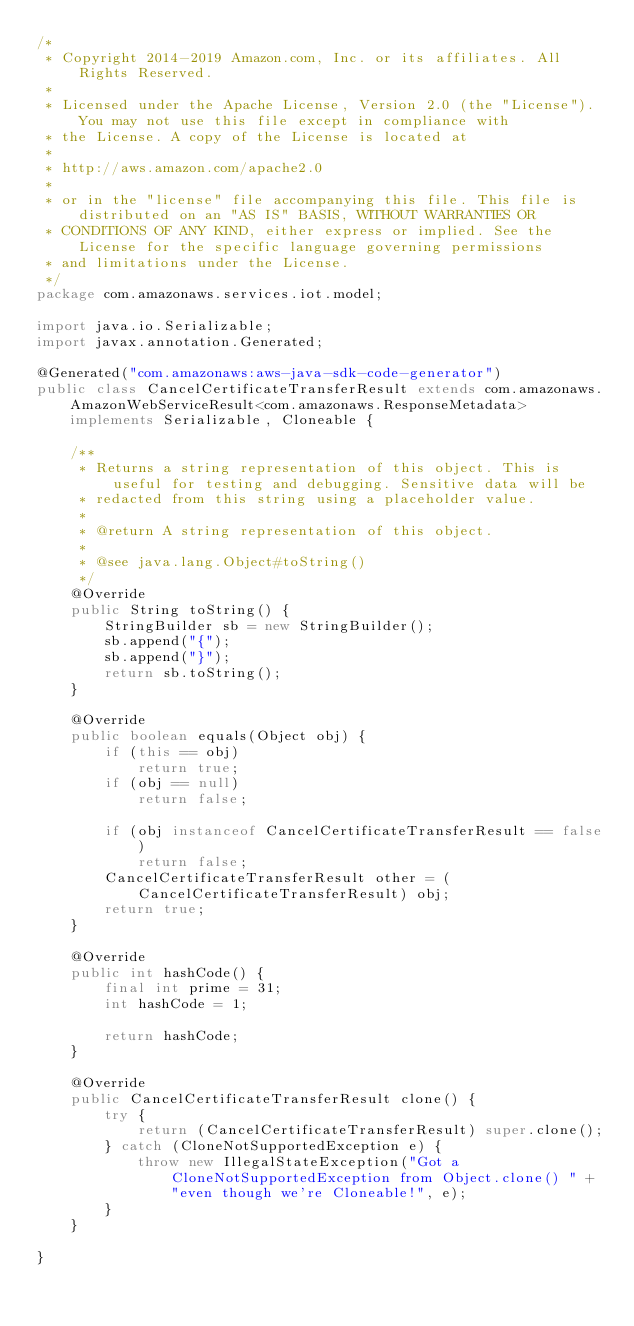<code> <loc_0><loc_0><loc_500><loc_500><_Java_>/*
 * Copyright 2014-2019 Amazon.com, Inc. or its affiliates. All Rights Reserved.
 * 
 * Licensed under the Apache License, Version 2.0 (the "License"). You may not use this file except in compliance with
 * the License. A copy of the License is located at
 * 
 * http://aws.amazon.com/apache2.0
 * 
 * or in the "license" file accompanying this file. This file is distributed on an "AS IS" BASIS, WITHOUT WARRANTIES OR
 * CONDITIONS OF ANY KIND, either express or implied. See the License for the specific language governing permissions
 * and limitations under the License.
 */
package com.amazonaws.services.iot.model;

import java.io.Serializable;
import javax.annotation.Generated;

@Generated("com.amazonaws:aws-java-sdk-code-generator")
public class CancelCertificateTransferResult extends com.amazonaws.AmazonWebServiceResult<com.amazonaws.ResponseMetadata> implements Serializable, Cloneable {

    /**
     * Returns a string representation of this object. This is useful for testing and debugging. Sensitive data will be
     * redacted from this string using a placeholder value.
     *
     * @return A string representation of this object.
     *
     * @see java.lang.Object#toString()
     */
    @Override
    public String toString() {
        StringBuilder sb = new StringBuilder();
        sb.append("{");
        sb.append("}");
        return sb.toString();
    }

    @Override
    public boolean equals(Object obj) {
        if (this == obj)
            return true;
        if (obj == null)
            return false;

        if (obj instanceof CancelCertificateTransferResult == false)
            return false;
        CancelCertificateTransferResult other = (CancelCertificateTransferResult) obj;
        return true;
    }

    @Override
    public int hashCode() {
        final int prime = 31;
        int hashCode = 1;

        return hashCode;
    }

    @Override
    public CancelCertificateTransferResult clone() {
        try {
            return (CancelCertificateTransferResult) super.clone();
        } catch (CloneNotSupportedException e) {
            throw new IllegalStateException("Got a CloneNotSupportedException from Object.clone() " + "even though we're Cloneable!", e);
        }
    }

}
</code> 